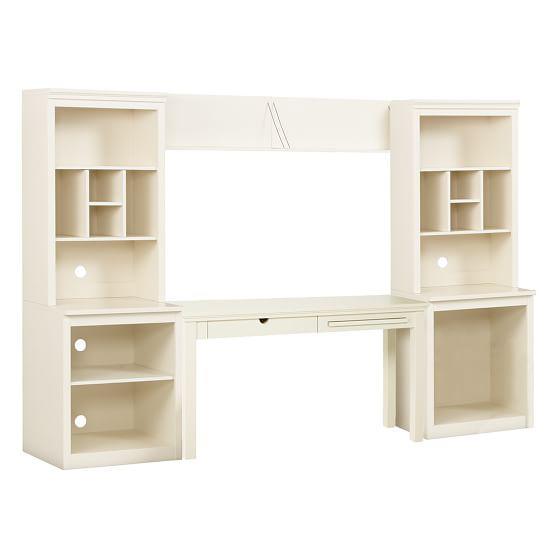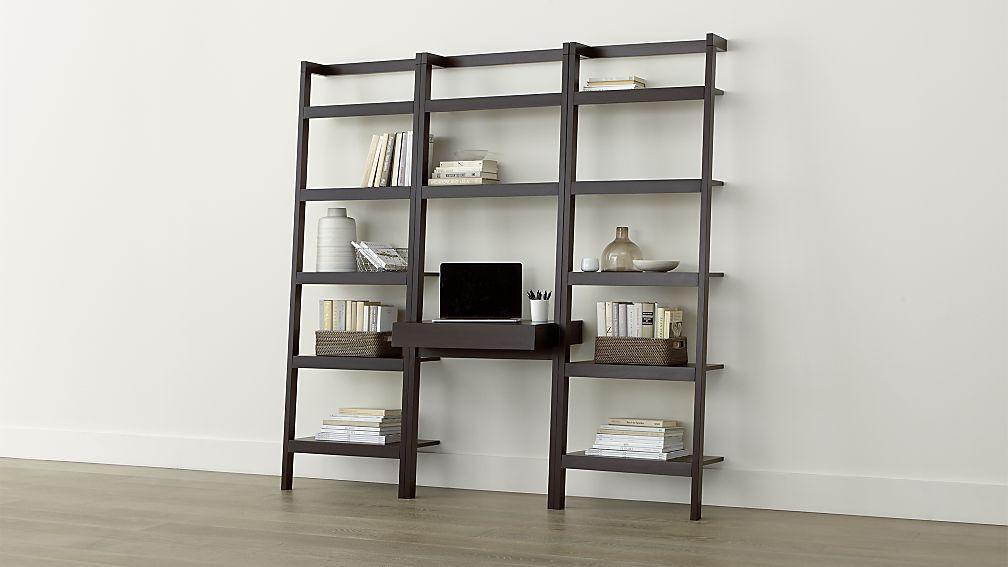The first image is the image on the left, the second image is the image on the right. For the images shown, is this caption "In one image, a bookshelf has three vertical shelf sections with a computer placed in the center unit." true? Answer yes or no. Yes. The first image is the image on the left, the second image is the image on the right. Examine the images to the left and right. Is the description "There us a white bookshelf with a laptop on it ,  a stack of books with a bowl on top of another stack of books are on the shelf above the laptop" accurate? Answer yes or no. No. 